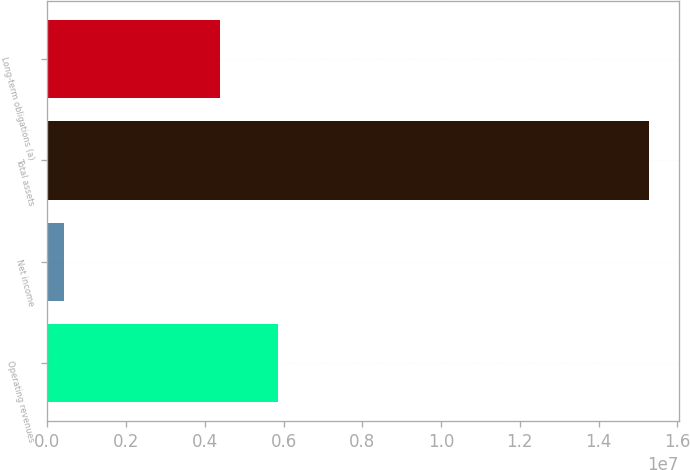Convert chart to OTSL. <chart><loc_0><loc_0><loc_500><loc_500><bar_chart><fcel>Operating revenues<fcel>Net income<fcel>Total assets<fcel>Long-term obligations (a)<nl><fcel>5.86945e+06<fcel>414126<fcel>1.52759e+07<fcel>4.38327e+06<nl></chart> 